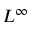<formula> <loc_0><loc_0><loc_500><loc_500>L ^ { \infty }</formula> 